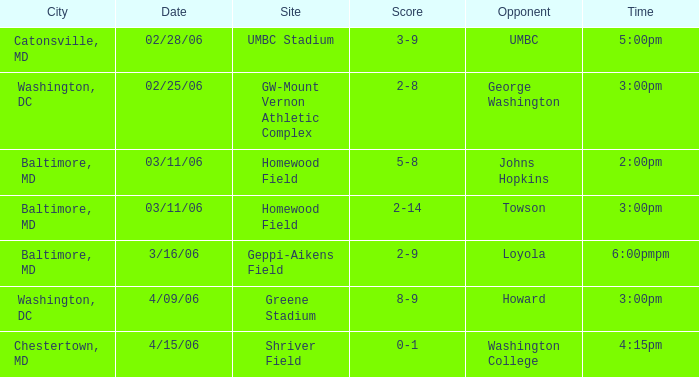Which Score has a Time of 5:00pm? 3-9. 